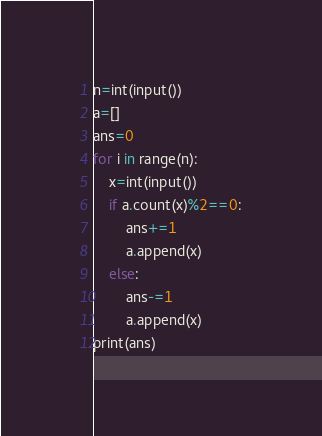Convert code to text. <code><loc_0><loc_0><loc_500><loc_500><_Python_>n=int(input())
a=[]
ans=0
for i in range(n):
    x=int(input())
    if a.count(x)%2==0:
        ans+=1
        a.append(x)
    else:
        ans-=1
        a.append(x)
print(ans)
</code> 